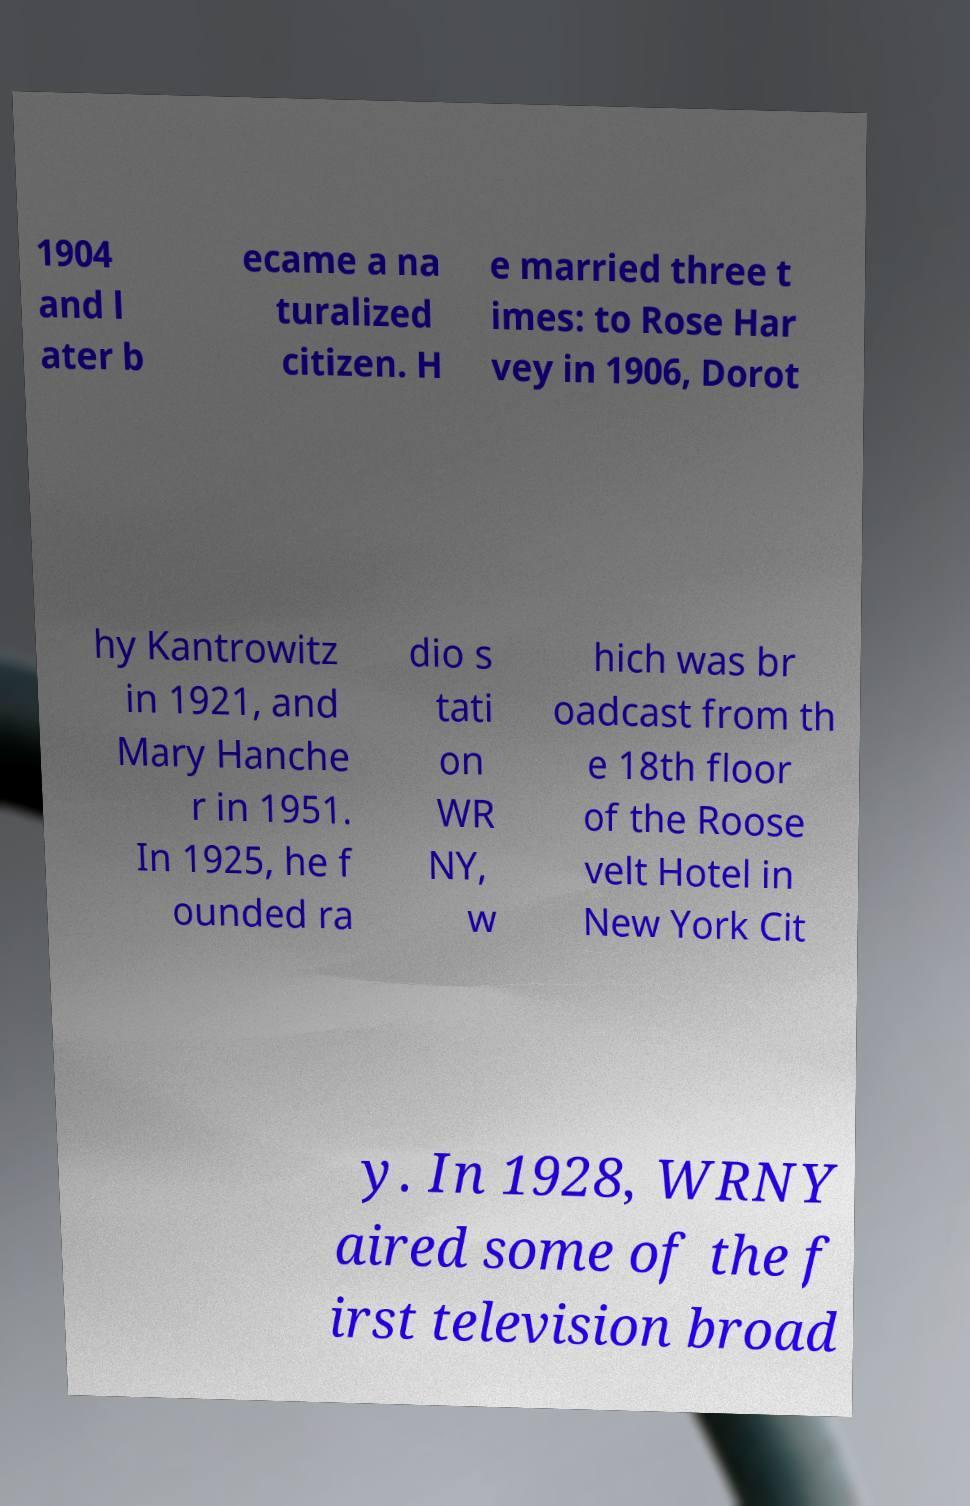For documentation purposes, I need the text within this image transcribed. Could you provide that? 1904 and l ater b ecame a na turalized citizen. H e married three t imes: to Rose Har vey in 1906, Dorot hy Kantrowitz in 1921, and Mary Hanche r in 1951. In 1925, he f ounded ra dio s tati on WR NY, w hich was br oadcast from th e 18th floor of the Roose velt Hotel in New York Cit y. In 1928, WRNY aired some of the f irst television broad 